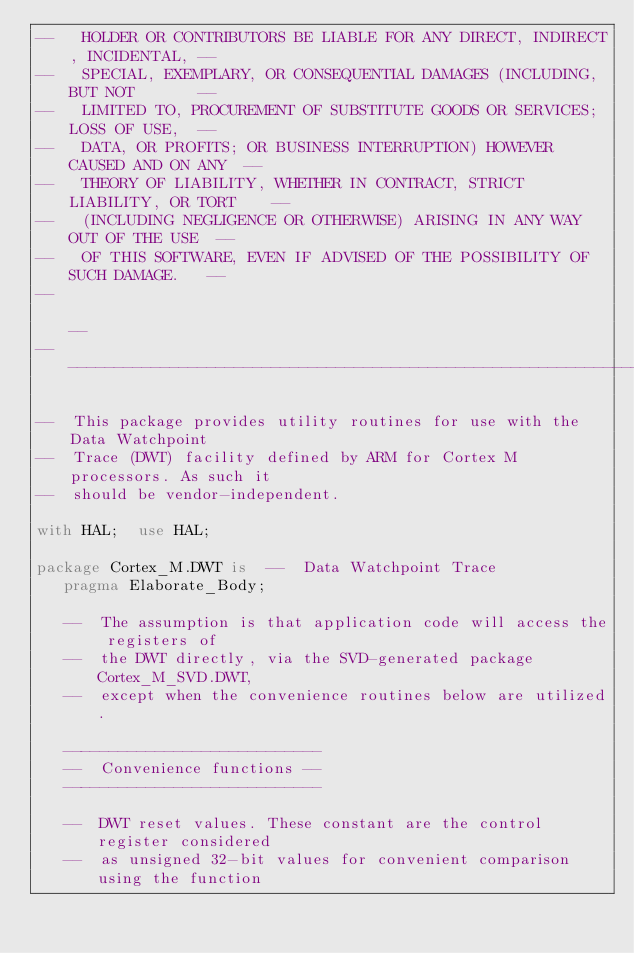Convert code to text. <code><loc_0><loc_0><loc_500><loc_500><_Ada_>--   HOLDER OR CONTRIBUTORS BE LIABLE FOR ANY DIRECT, INDIRECT, INCIDENTAL, --
--   SPECIAL, EXEMPLARY, OR CONSEQUENTIAL DAMAGES (INCLUDING, BUT NOT       --
--   LIMITED TO, PROCUREMENT OF SUBSTITUTE GOODS OR SERVICES; LOSS OF USE,  --
--   DATA, OR PROFITS; OR BUSINESS INTERRUPTION) HOWEVER CAUSED AND ON ANY  --
--   THEORY OF LIABILITY, WHETHER IN CONTRACT, STRICT LIABILITY, OR TORT    --
--   (INCLUDING NEGLIGENCE OR OTHERWISE) ARISING IN ANY WAY OUT OF THE USE  --
--   OF THIS SOFTWARE, EVEN IF ADVISED OF THE POSSIBILITY OF SUCH DAMAGE.   --
--                                                                          --
------------------------------------------------------------------------------

--  This package provides utility routines for use with the Data Watchpoint
--  Trace (DWT) facility defined by ARM for Cortex M processors. As such it
--  should be vendor-independent.

with HAL;  use HAL;

package Cortex_M.DWT is  --  Data Watchpoint Trace
   pragma Elaborate_Body;

   --  The assumption is that application code will access the registers of
   --  the DWT directly, via the SVD-generated package Cortex_M_SVD.DWT,
   --  except when the convenience routines below are utilized.

   ----------------------------
   --  Convenience functions --
   ----------------------------

   --  DWT reset values. These constant are the control register considered
   --  as unsigned 32-bit values for convenient comparison using the function</code> 